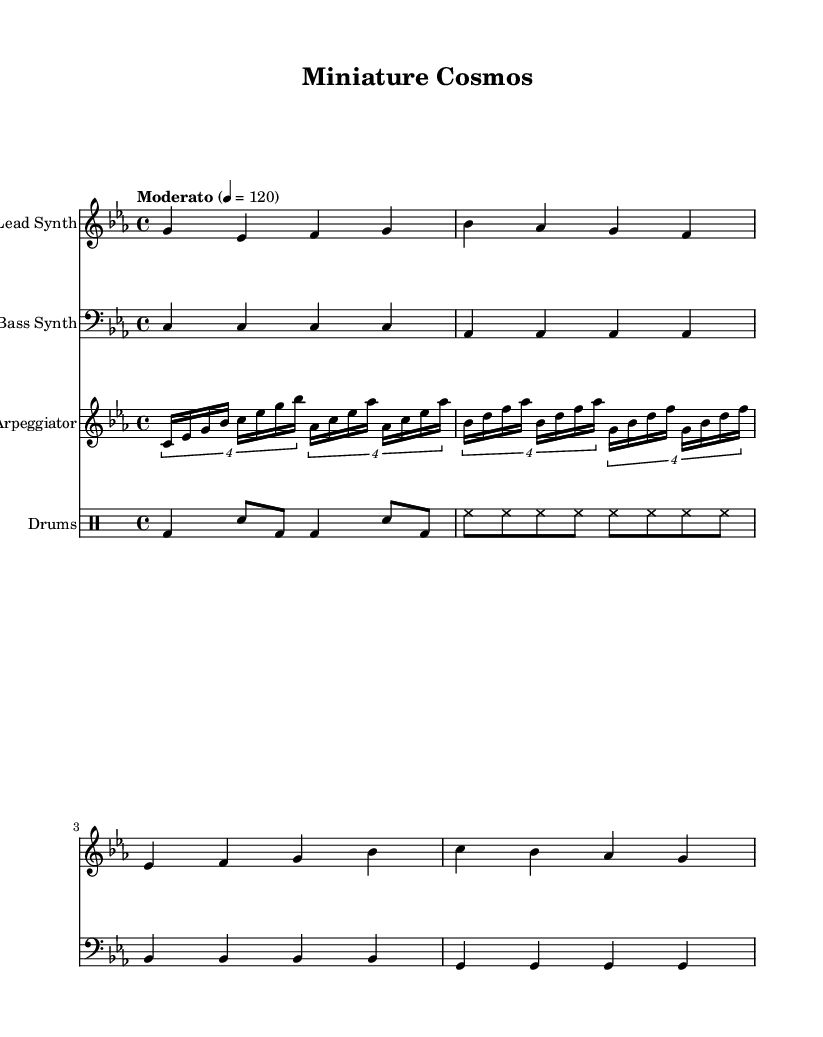What is the key signature of this music? The key signature is C minor, indicated by three flats in the key signature.
Answer: C minor What is the time signature of this music? The time signature is indicated by the "4/4" marking at the beginning of the score, which shows that there are four beats per measure and the quarter note receives one beat.
Answer: 4/4 What is the tempo marking of the piece? The tempo marking states "Moderato" with a metronome marking of "4 = 120," meaning it should be played in a moderately fast pace at 120 beats per minute.
Answer: Moderato How many measures are there in the lead synth part? The lead synth part consists of four measures, each separated by vertical lines that indicate measure endings.
Answer: 4 What is the rhythmic pattern of the bass synth part? The bass synth part consists of quarter notes played on each beat for the first four measures, creating a consistent rhythmic pattern.
Answer: Quarter notes Which instruments are included in this score? The score features a lead synth, bass synth, arpeggiator, and drums, noted by the respective instrument names in their staves.
Answer: Lead Synth, Bass Synth, Arpeggiator, Drums What kind of sound does the arpeggiator create? The arpeggiator creates a rapid sequence of notes evidenced by the tuplet notation showing groups of notes played in a set rhythm, typical of retro synth sounds.
Answer: Rapid sequence 